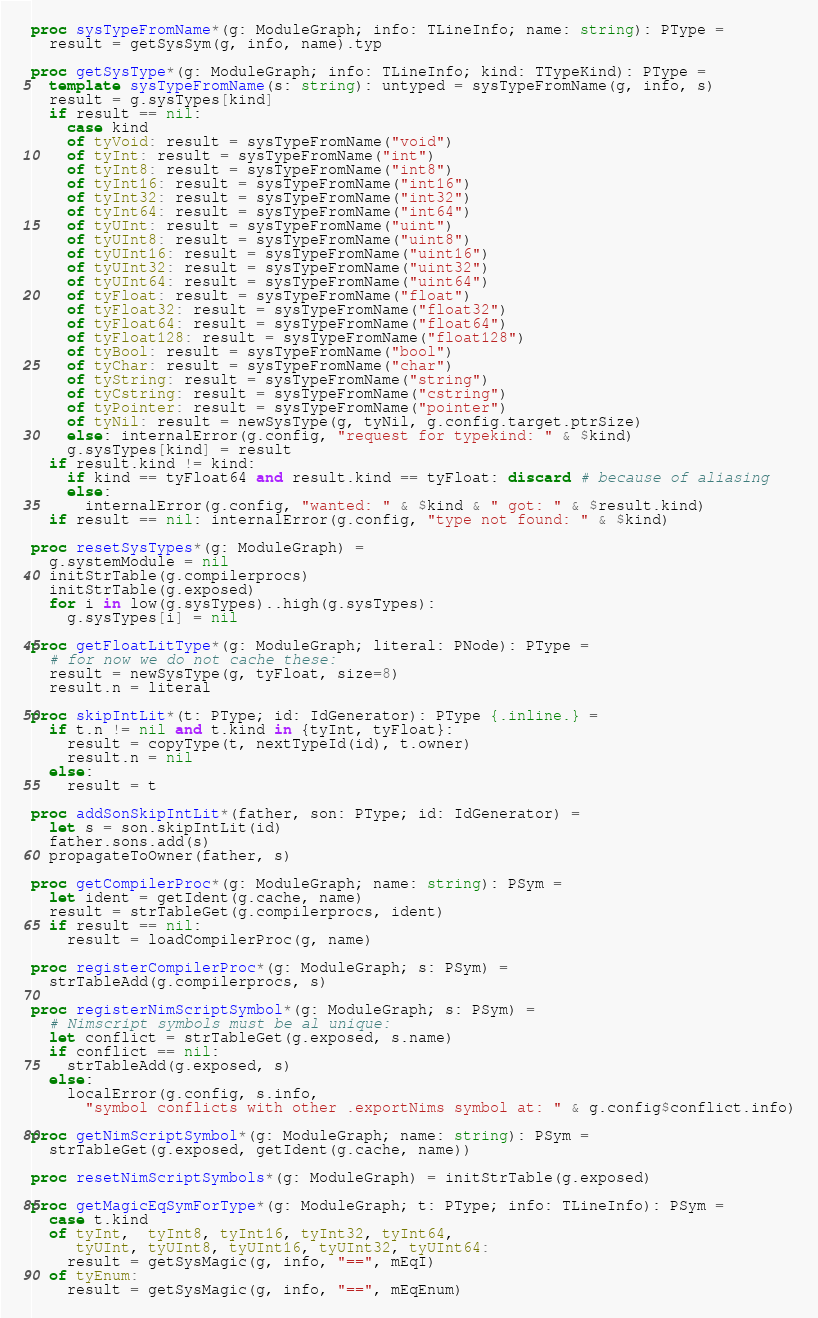Convert code to text. <code><loc_0><loc_0><loc_500><loc_500><_Nim_>proc sysTypeFromName*(g: ModuleGraph; info: TLineInfo; name: string): PType =
  result = getSysSym(g, info, name).typ

proc getSysType*(g: ModuleGraph; info: TLineInfo; kind: TTypeKind): PType =
  template sysTypeFromName(s: string): untyped = sysTypeFromName(g, info, s)
  result = g.sysTypes[kind]
  if result == nil:
    case kind
    of tyVoid: result = sysTypeFromName("void")
    of tyInt: result = sysTypeFromName("int")
    of tyInt8: result = sysTypeFromName("int8")
    of tyInt16: result = sysTypeFromName("int16")
    of tyInt32: result = sysTypeFromName("int32")
    of tyInt64: result = sysTypeFromName("int64")
    of tyUInt: result = sysTypeFromName("uint")
    of tyUInt8: result = sysTypeFromName("uint8")
    of tyUInt16: result = sysTypeFromName("uint16")
    of tyUInt32: result = sysTypeFromName("uint32")
    of tyUInt64: result = sysTypeFromName("uint64")
    of tyFloat: result = sysTypeFromName("float")
    of tyFloat32: result = sysTypeFromName("float32")
    of tyFloat64: result = sysTypeFromName("float64")
    of tyFloat128: result = sysTypeFromName("float128")
    of tyBool: result = sysTypeFromName("bool")
    of tyChar: result = sysTypeFromName("char")
    of tyString: result = sysTypeFromName("string")
    of tyCstring: result = sysTypeFromName("cstring")
    of tyPointer: result = sysTypeFromName("pointer")
    of tyNil: result = newSysType(g, tyNil, g.config.target.ptrSize)
    else: internalError(g.config, "request for typekind: " & $kind)
    g.sysTypes[kind] = result
  if result.kind != kind:
    if kind == tyFloat64 and result.kind == tyFloat: discard # because of aliasing
    else:
      internalError(g.config, "wanted: " & $kind & " got: " & $result.kind)
  if result == nil: internalError(g.config, "type not found: " & $kind)

proc resetSysTypes*(g: ModuleGraph) =
  g.systemModule = nil
  initStrTable(g.compilerprocs)
  initStrTable(g.exposed)
  for i in low(g.sysTypes)..high(g.sysTypes):
    g.sysTypes[i] = nil

proc getFloatLitType*(g: ModuleGraph; literal: PNode): PType =
  # for now we do not cache these:
  result = newSysType(g, tyFloat, size=8)
  result.n = literal

proc skipIntLit*(t: PType; id: IdGenerator): PType {.inline.} =
  if t.n != nil and t.kind in {tyInt, tyFloat}:
    result = copyType(t, nextTypeId(id), t.owner)
    result.n = nil
  else:
    result = t

proc addSonSkipIntLit*(father, son: PType; id: IdGenerator) =
  let s = son.skipIntLit(id)
  father.sons.add(s)
  propagateToOwner(father, s)

proc getCompilerProc*(g: ModuleGraph; name: string): PSym =
  let ident = getIdent(g.cache, name)
  result = strTableGet(g.compilerprocs, ident)
  if result == nil:
    result = loadCompilerProc(g, name)

proc registerCompilerProc*(g: ModuleGraph; s: PSym) =
  strTableAdd(g.compilerprocs, s)

proc registerNimScriptSymbol*(g: ModuleGraph; s: PSym) =
  # Nimscript symbols must be al unique:
  let conflict = strTableGet(g.exposed, s.name)
  if conflict == nil:
    strTableAdd(g.exposed, s)
  else:
    localError(g.config, s.info,
      "symbol conflicts with other .exportNims symbol at: " & g.config$conflict.info)

proc getNimScriptSymbol*(g: ModuleGraph; name: string): PSym =
  strTableGet(g.exposed, getIdent(g.cache, name))

proc resetNimScriptSymbols*(g: ModuleGraph) = initStrTable(g.exposed)

proc getMagicEqSymForType*(g: ModuleGraph; t: PType; info: TLineInfo): PSym =
  case t.kind
  of tyInt,  tyInt8, tyInt16, tyInt32, tyInt64,
     tyUInt, tyUInt8, tyUInt16, tyUInt32, tyUInt64:
    result = getSysMagic(g, info, "==", mEqI)
  of tyEnum:
    result = getSysMagic(g, info, "==", mEqEnum)</code> 